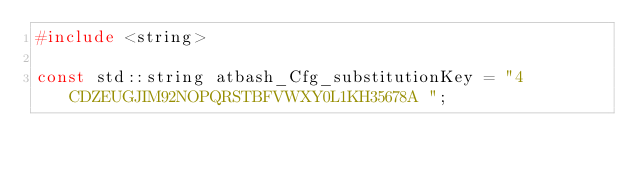<code> <loc_0><loc_0><loc_500><loc_500><_C_>#include <string>

const std::string atbash_Cfg_substitutionKey = "4CDZEUGJIM92NOPQRSTBFVWXY0L1KH35678A ";
</code> 